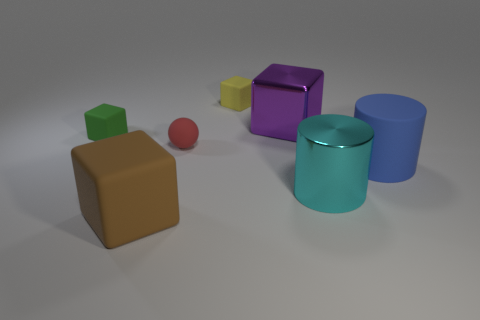Subtract all tiny green rubber cubes. How many cubes are left? 3 Add 3 small rubber balls. How many objects exist? 10 Subtract all brown blocks. How many blocks are left? 3 Subtract 2 cylinders. How many cylinders are left? 0 Subtract all cylinders. How many objects are left? 5 Subtract all purple metallic things. Subtract all cyan metallic things. How many objects are left? 5 Add 1 large cyan shiny cylinders. How many large cyan shiny cylinders are left? 2 Add 1 small green balls. How many small green balls exist? 1 Subtract 0 cyan cubes. How many objects are left? 7 Subtract all yellow blocks. Subtract all red balls. How many blocks are left? 3 